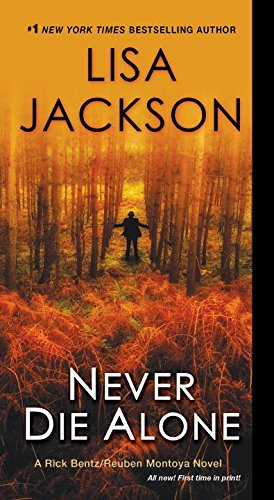What is the title of this book? The title of the book shown is 'Never Die Alone', a gripping entry in the Bentz/Montoya series, which promises intense mystery and suspense. 